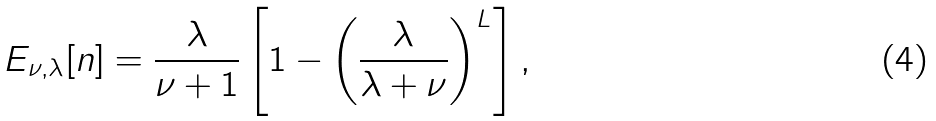<formula> <loc_0><loc_0><loc_500><loc_500>E _ { \nu , \lambda } [ n ] = \frac { \lambda } { \nu + 1 } \left [ 1 - \left ( \frac { \lambda } { \lambda + \nu } \right ) ^ { L } \right ] ,</formula> 